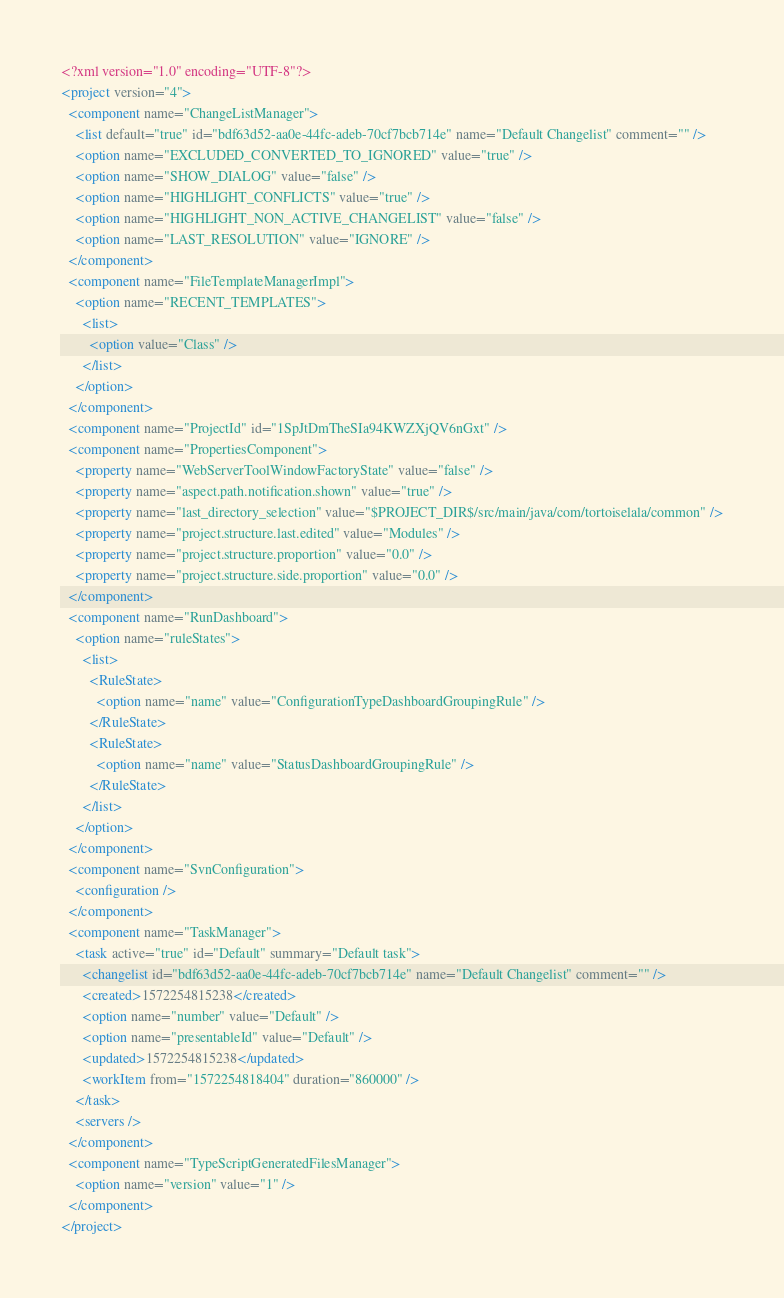<code> <loc_0><loc_0><loc_500><loc_500><_XML_><?xml version="1.0" encoding="UTF-8"?>
<project version="4">
  <component name="ChangeListManager">
    <list default="true" id="bdf63d52-aa0e-44fc-adeb-70cf7bcb714e" name="Default Changelist" comment="" />
    <option name="EXCLUDED_CONVERTED_TO_IGNORED" value="true" />
    <option name="SHOW_DIALOG" value="false" />
    <option name="HIGHLIGHT_CONFLICTS" value="true" />
    <option name="HIGHLIGHT_NON_ACTIVE_CHANGELIST" value="false" />
    <option name="LAST_RESOLUTION" value="IGNORE" />
  </component>
  <component name="FileTemplateManagerImpl">
    <option name="RECENT_TEMPLATES">
      <list>
        <option value="Class" />
      </list>
    </option>
  </component>
  <component name="ProjectId" id="1SpJtDmTheSIa94KWZXjQV6nGxt" />
  <component name="PropertiesComponent">
    <property name="WebServerToolWindowFactoryState" value="false" />
    <property name="aspect.path.notification.shown" value="true" />
    <property name="last_directory_selection" value="$PROJECT_DIR$/src/main/java/com/tortoiselala/common" />
    <property name="project.structure.last.edited" value="Modules" />
    <property name="project.structure.proportion" value="0.0" />
    <property name="project.structure.side.proportion" value="0.0" />
  </component>
  <component name="RunDashboard">
    <option name="ruleStates">
      <list>
        <RuleState>
          <option name="name" value="ConfigurationTypeDashboardGroupingRule" />
        </RuleState>
        <RuleState>
          <option name="name" value="StatusDashboardGroupingRule" />
        </RuleState>
      </list>
    </option>
  </component>
  <component name="SvnConfiguration">
    <configuration />
  </component>
  <component name="TaskManager">
    <task active="true" id="Default" summary="Default task">
      <changelist id="bdf63d52-aa0e-44fc-adeb-70cf7bcb714e" name="Default Changelist" comment="" />
      <created>1572254815238</created>
      <option name="number" value="Default" />
      <option name="presentableId" value="Default" />
      <updated>1572254815238</updated>
      <workItem from="1572254818404" duration="860000" />
    </task>
    <servers />
  </component>
  <component name="TypeScriptGeneratedFilesManager">
    <option name="version" value="1" />
  </component>
</project></code> 